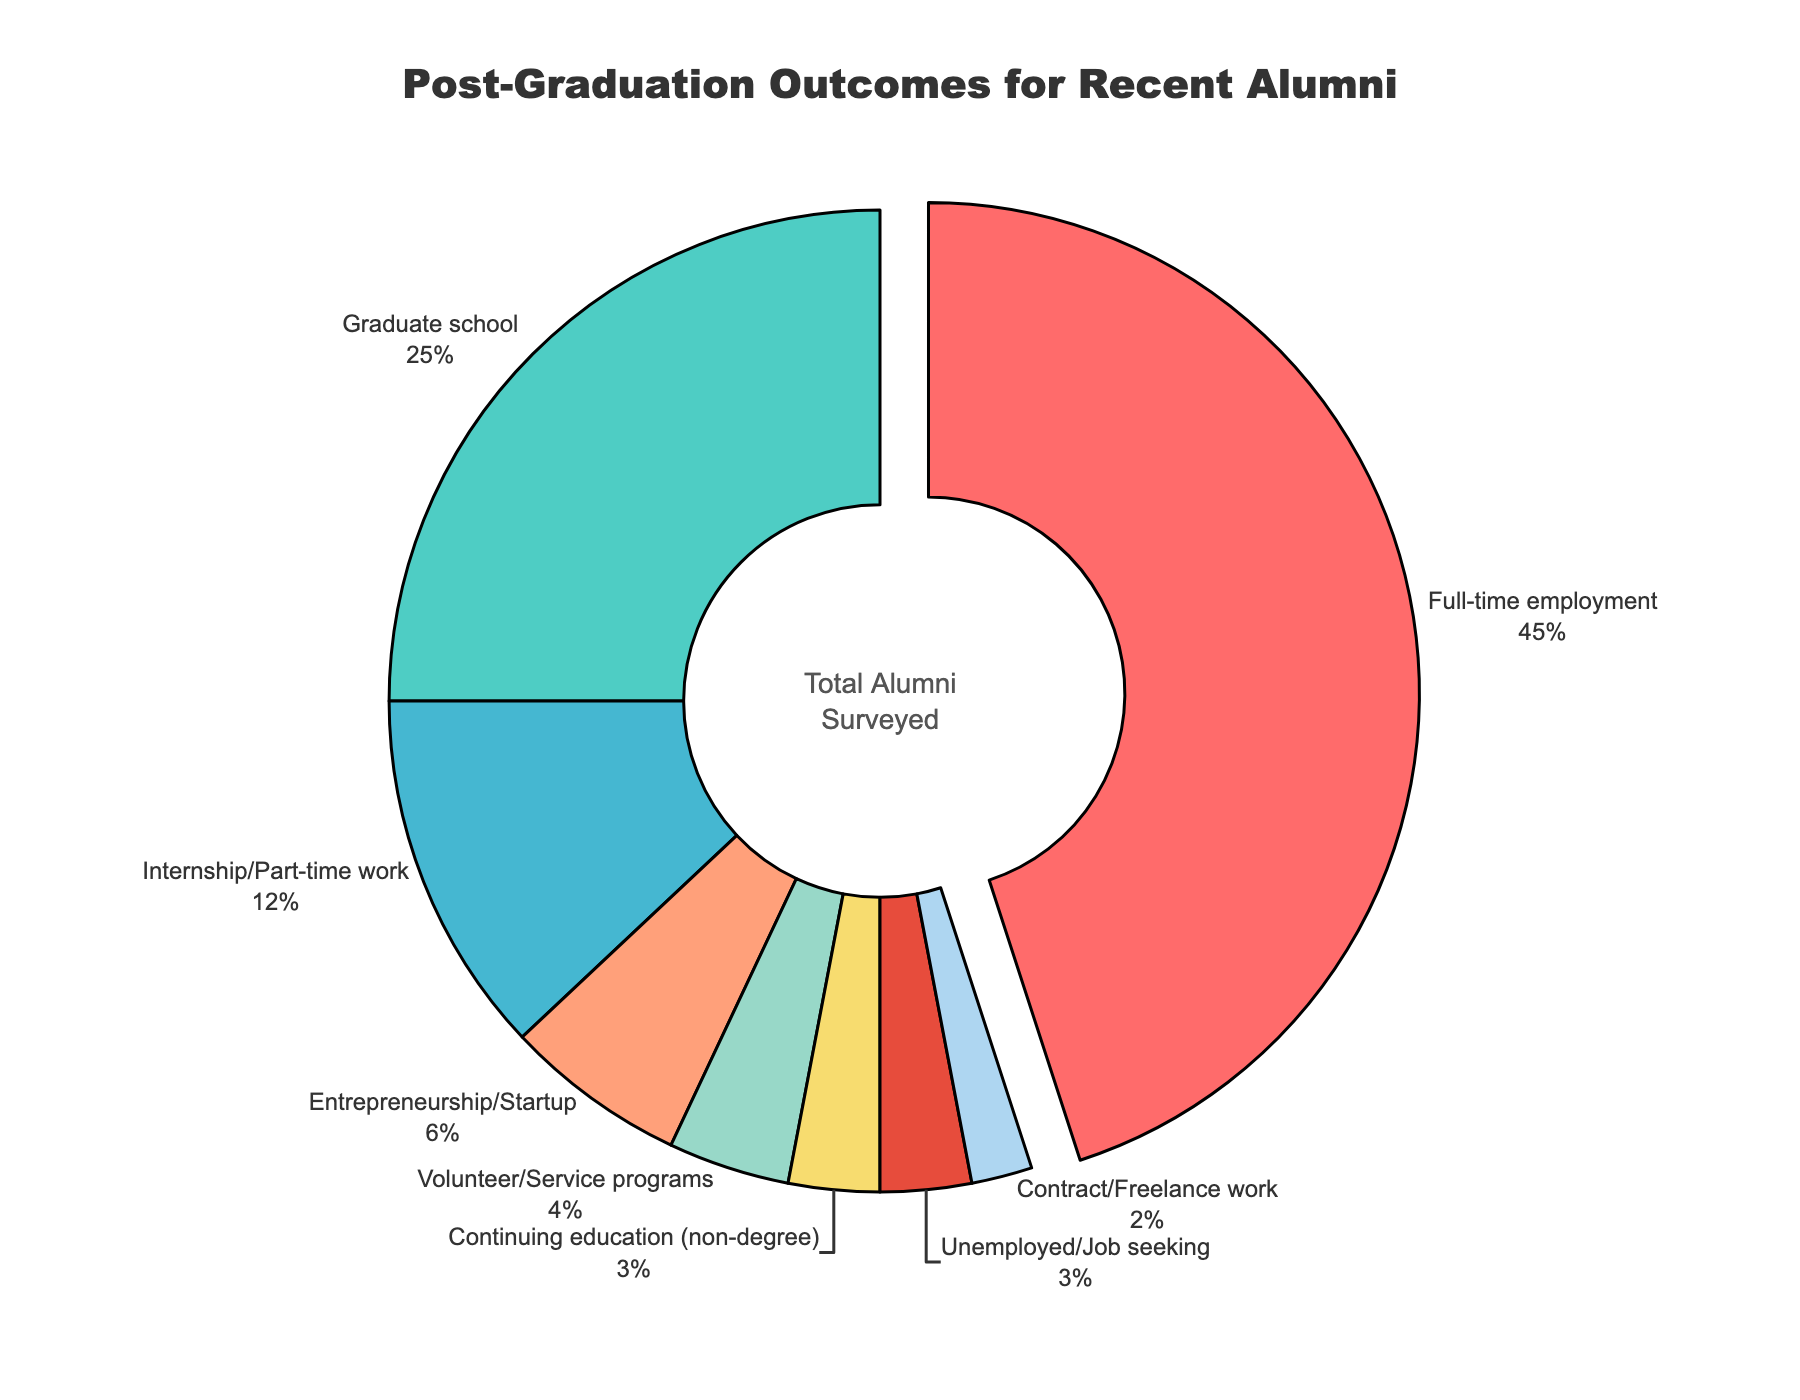What percentage of recent alumni are either unemployed or continuing education (non-degree)? To find the percentage of alumni who are either unemployed or continuing education (non-degree), add the percentages for both categories: 3% (Unemployed/Job seeking) + 3% (Continuing education) = 6%.
Answer: 6% Which sector has the highest percentage of recent alumni? The sector with the highest percentage is visually the largest slice, with a slight pull indicating emphasis. According to the data, Full-time employment has the highest percentage of 45%.
Answer: Full-time employment How much higher is the percentage of alumni in full-time employment compared to those in volunteer/service programs? Subtract the percentage of alumni in volunteer/service programs from those in full-time employment: 45% (Full-time employment) - 4% (Volunteer/Service programs) = 41%.
Answer: 41% What proportion of alumni are engaged in some form of further education (graduate school + continuing education)? Add the percentages of alumni in graduate school and continuing education: 25% (Graduate school) + 3% (Continuing education) = 28%.
Answer: 28% Which sectors occupy the smallest slices in the chart? The slices corresponding to Contract/Freelance work and Unemployed/Job seeking are the smallest, each representing 2% and 3% respectively.
Answer: Contract/Freelance work and Unemployed/Job seeking Compare the combined percentage of alumni in internships/part-time work and entrepreneurship/startup to those in graduate school. Sum the percentages for internships/part-time work and entrepreneurship/startup, then compare to graduate school: 12% (Internship/Part-time work) + 6% (Entrepreneurship/Startup) = 18%. The percentage in graduate school is 25%.
Answer: 18% compared to 25% Is the percentage of recent alumni in volunteer/service programs greater than those in contract/freelance work? Compare the given percentages: 4% (Volunteer/Service programs) vs. 2% (Contract/Freelance work). Since 4% is greater than 2%, the answer is yes.
Answer: Yes Find the difference between the percentages of graduate school alumni and those participating in internship/part-time work. Subtract the percentage of internship/part-time work from graduate school: 25% (Graduate school) - 12% (Internship/Part-time work) = 13%.
Answer: 13% How many sectors have a representation of 5% or less? Identify sectors with 5% or less: Internship/Part-time work (12%), Entrepreneurship/Startup (6%), Volunteer/Service programs (4%), Continuing education (3%), Unemployed/Job seeking (3%), Contract/Freelance work (2%). Count the qualifying sectors: 4% (Volunteer/Service programs), 3% (Continuing education), 3% (Unemployed/Job seeking), 2% (Contract/Freelance work). Total = 4.
Answer: 4 